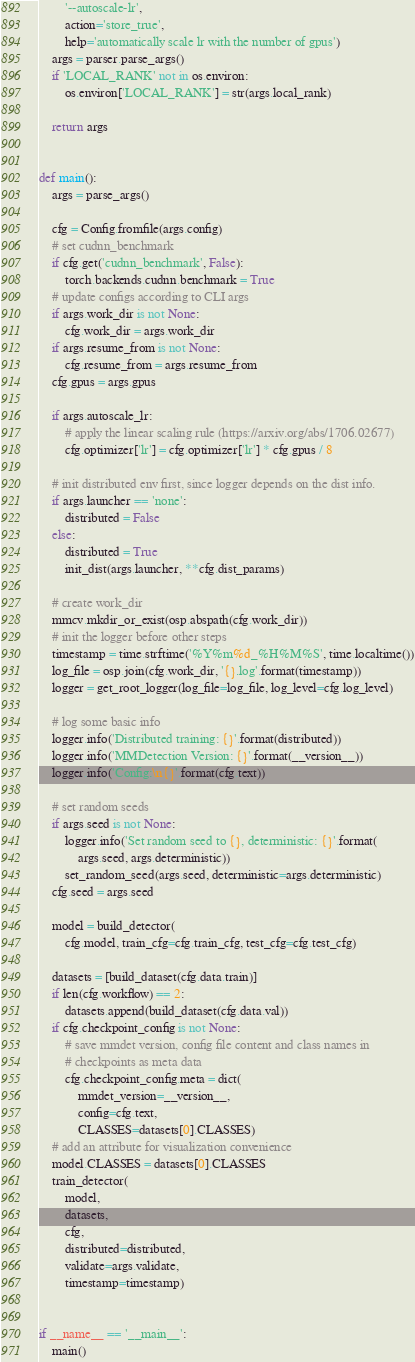<code> <loc_0><loc_0><loc_500><loc_500><_Python_>        '--autoscale-lr',
        action='store_true',
        help='automatically scale lr with the number of gpus')
    args = parser.parse_args()
    if 'LOCAL_RANK' not in os.environ:
        os.environ['LOCAL_RANK'] = str(args.local_rank)

    return args


def main():
    args = parse_args()

    cfg = Config.fromfile(args.config)
    # set cudnn_benchmark
    if cfg.get('cudnn_benchmark', False):
        torch.backends.cudnn.benchmark = True
    # update configs according to CLI args
    if args.work_dir is not None:
        cfg.work_dir = args.work_dir
    if args.resume_from is not None:
        cfg.resume_from = args.resume_from
    cfg.gpus = args.gpus

    if args.autoscale_lr:
        # apply the linear scaling rule (https://arxiv.org/abs/1706.02677)
        cfg.optimizer['lr'] = cfg.optimizer['lr'] * cfg.gpus / 8

    # init distributed env first, since logger depends on the dist info.
    if args.launcher == 'none':
        distributed = False
    else:
        distributed = True
        init_dist(args.launcher, **cfg.dist_params)

    # create work_dir
    mmcv.mkdir_or_exist(osp.abspath(cfg.work_dir))
    # init the logger before other steps
    timestamp = time.strftime('%Y%m%d_%H%M%S', time.localtime())
    log_file = osp.join(cfg.work_dir, '{}.log'.format(timestamp))
    logger = get_root_logger(log_file=log_file, log_level=cfg.log_level)

    # log some basic info
    logger.info('Distributed training: {}'.format(distributed))
    logger.info('MMDetection Version: {}'.format(__version__))
    logger.info('Config:\n{}'.format(cfg.text))

    # set random seeds
    if args.seed is not None:
        logger.info('Set random seed to {}, deterministic: {}'.format(
            args.seed, args.deterministic))
        set_random_seed(args.seed, deterministic=args.deterministic)
    cfg.seed = args.seed

    model = build_detector(
        cfg.model, train_cfg=cfg.train_cfg, test_cfg=cfg.test_cfg)

    datasets = [build_dataset(cfg.data.train)]
    if len(cfg.workflow) == 2:
        datasets.append(build_dataset(cfg.data.val))
    if cfg.checkpoint_config is not None:
        # save mmdet version, config file content and class names in
        # checkpoints as meta data
        cfg.checkpoint_config.meta = dict(
            mmdet_version=__version__,
            config=cfg.text,
            CLASSES=datasets[0].CLASSES)
    # add an attribute for visualization convenience
    model.CLASSES = datasets[0].CLASSES
    train_detector(
        model,
        datasets,
        cfg,
        distributed=distributed,
        validate=args.validate,
        timestamp=timestamp)


if __name__ == '__main__':
    main()
</code> 